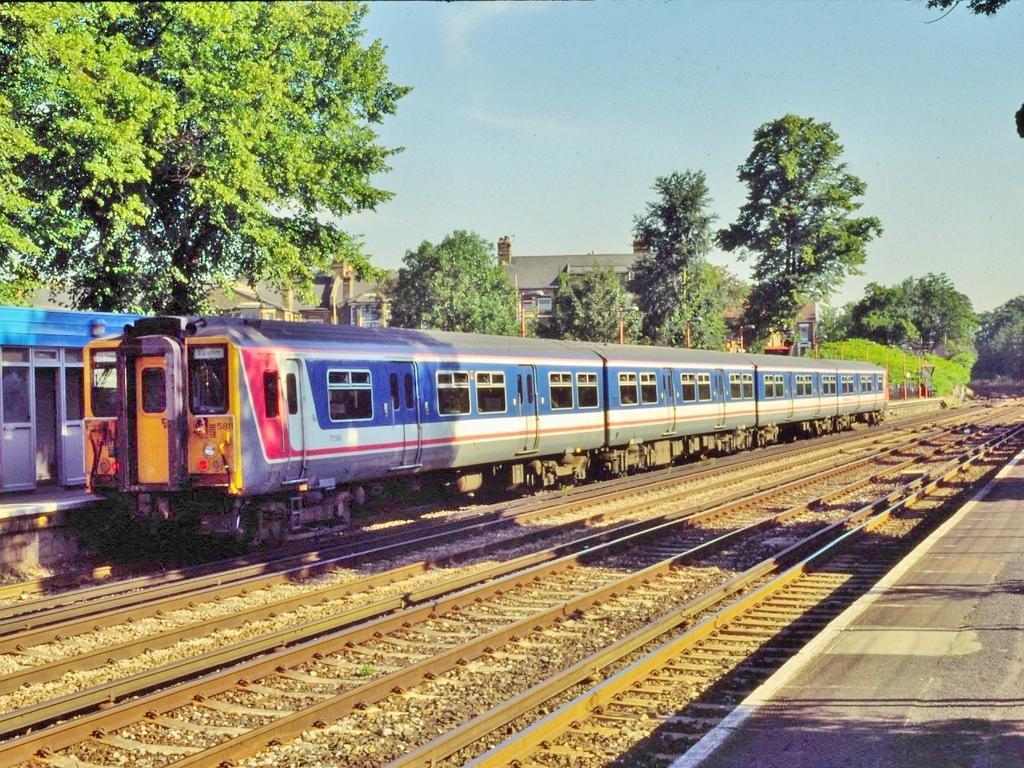In one or two sentences, can you explain what this image depicts? In this image I can see few railway tracks and on it I can see blue colour train. I can also see shadows, number of trees, buildings and the sky. 